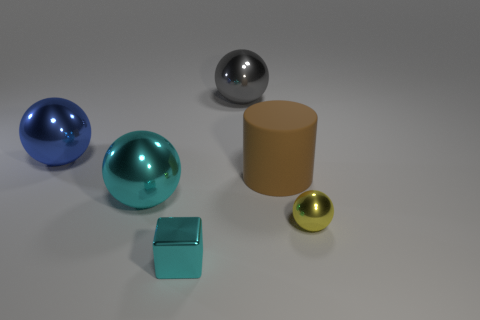There is a large metallic thing that is the same color as the small block; what shape is it?
Keep it short and to the point. Sphere. Do the metallic cube and the big ball that is right of the cyan shiny cube have the same color?
Your answer should be very brief. No. Is the number of shiny objects left of the large blue shiny object greater than the number of big things?
Provide a succinct answer. No. What number of things are yellow balls that are behind the tiny cyan thing or metallic spheres on the left side of the cyan sphere?
Keep it short and to the point. 2. The yellow sphere that is the same material as the block is what size?
Your response must be concise. Small. There is a cyan object that is behind the cube; does it have the same shape as the big gray metal thing?
Ensure brevity in your answer.  Yes. There is a thing that is the same color as the tiny block; what is its size?
Keep it short and to the point. Large. How many gray things are either large spheres or large things?
Provide a short and direct response. 1. How many other things are the same shape as the large cyan shiny thing?
Ensure brevity in your answer.  3. What shape is the thing that is both right of the tiny cyan block and behind the big matte cylinder?
Offer a very short reply. Sphere. 